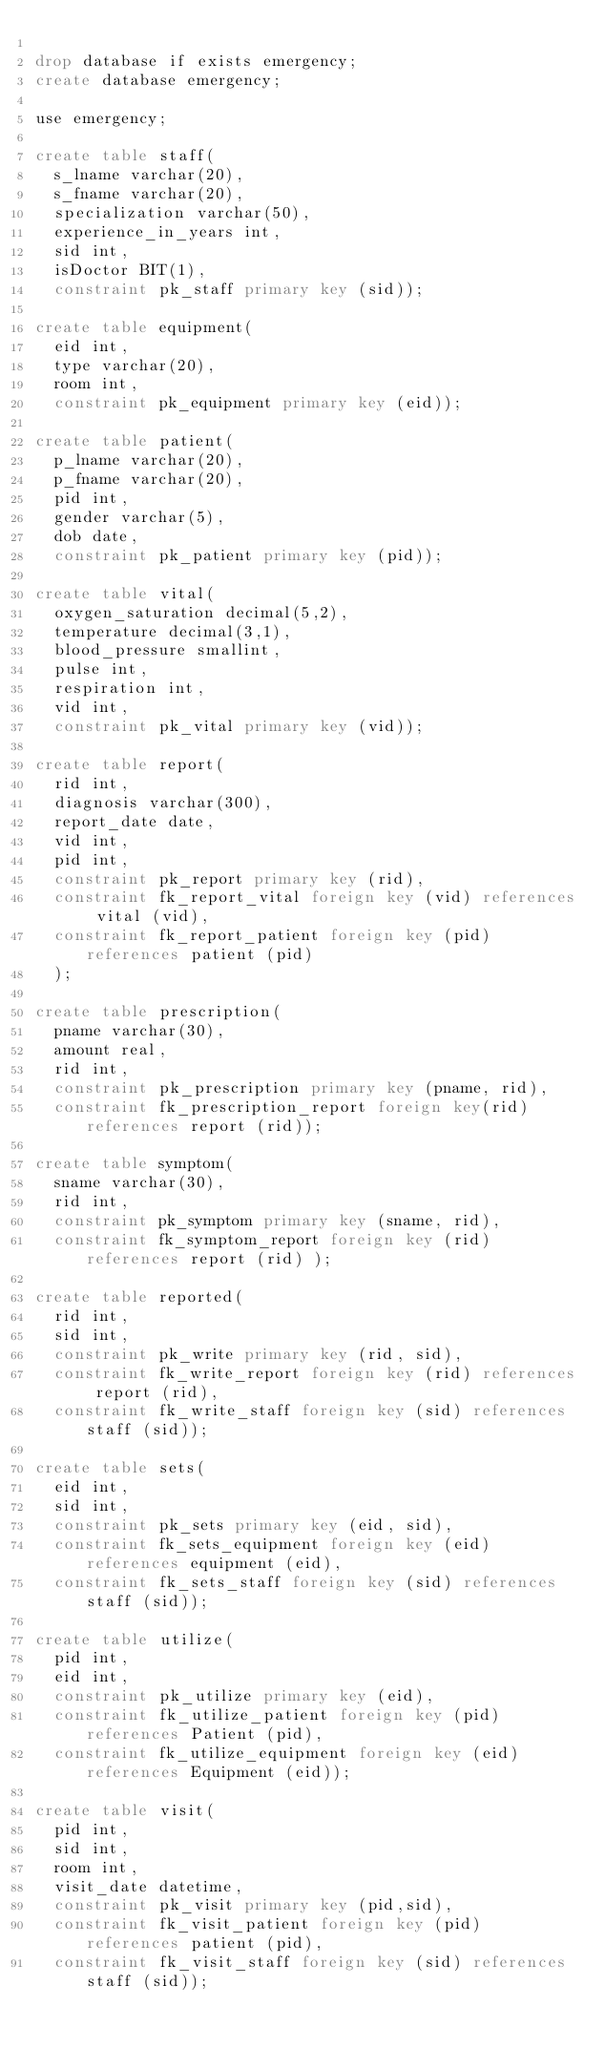<code> <loc_0><loc_0><loc_500><loc_500><_SQL_>
drop database if exists emergency;
create database emergency;

use emergency;

create table staff(
	s_lname varchar(20),
	s_fname varchar(20),
	specialization varchar(50),
	experience_in_years int,
	sid int,
	isDoctor BIT(1),
	constraint pk_staff primary key (sid));

create table equipment(
	eid int,
	type varchar(20),
	room int,
	constraint pk_equipment primary key (eid));

create table patient(
	p_lname varchar(20),
	p_fname varchar(20),
	pid int,
	gender varchar(5),
	dob date,
	constraint pk_patient primary key (pid));

create table vital(
	oxygen_saturation decimal(5,2),
	temperature decimal(3,1),
	blood_pressure smallint,
	pulse int,
	respiration int,
	vid int,
	constraint pk_vital primary key (vid));

create table report(
	rid int,
	diagnosis varchar(300),
	report_date date,
	vid int,
	pid int,
	constraint pk_report primary key (rid),
	constraint fk_report_vital foreign key (vid) references vital (vid),
	constraint fk_report_patient foreign key (pid) references patient (pid)
	);

create table prescription(
	pname varchar(30),
	amount real,
	rid int,
	constraint pk_prescription primary key (pname, rid),
	constraint fk_prescription_report foreign key(rid) references report (rid));

create table symptom(
	sname varchar(30),
	rid int,
	constraint pk_symptom primary key (sname, rid),
	constraint fk_symptom_report foreign key (rid) references report (rid) );

create table reported(
	rid int,
	sid int,
	constraint pk_write primary key (rid, sid),
	constraint fk_write_report foreign key (rid) references report (rid),
	constraint fk_write_staff foreign key (sid) references staff (sid));

create table sets(
	eid int,
	sid int,
	constraint pk_sets primary key (eid, sid),
	constraint fk_sets_equipment foreign key (eid) references equipment (eid),
	constraint fk_sets_staff foreign key (sid) references staff (sid));

create table utilize(
	pid int,
	eid int,
	constraint pk_utilize primary key (eid),
	constraint fk_utilize_patient foreign key (pid) references Patient (pid),
	constraint fk_utilize_equipment foreign key (eid) references Equipment (eid));

create table visit(
	pid int,
	sid int,
	room int,
	visit_date datetime,
	constraint pk_visit primary key (pid,sid),
	constraint fk_visit_patient foreign key (pid) references patient (pid),
	constraint fk_visit_staff foreign key (sid) references staff (sid));

</code> 